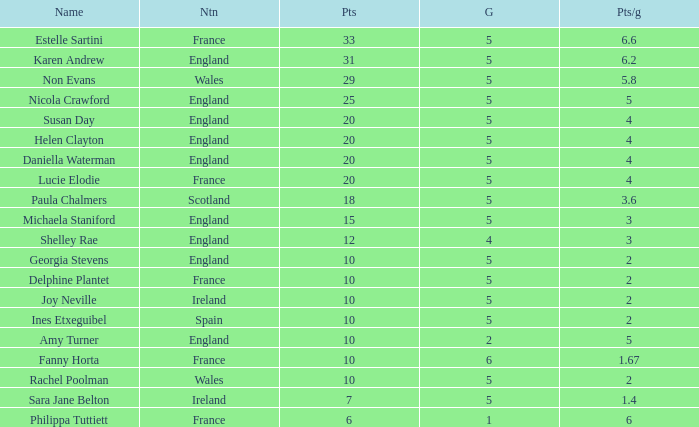Can you tell me the lowest Games that has the Pts/game larger than 1.4 and the Points of 20, and the Name of susan day? 5.0. 